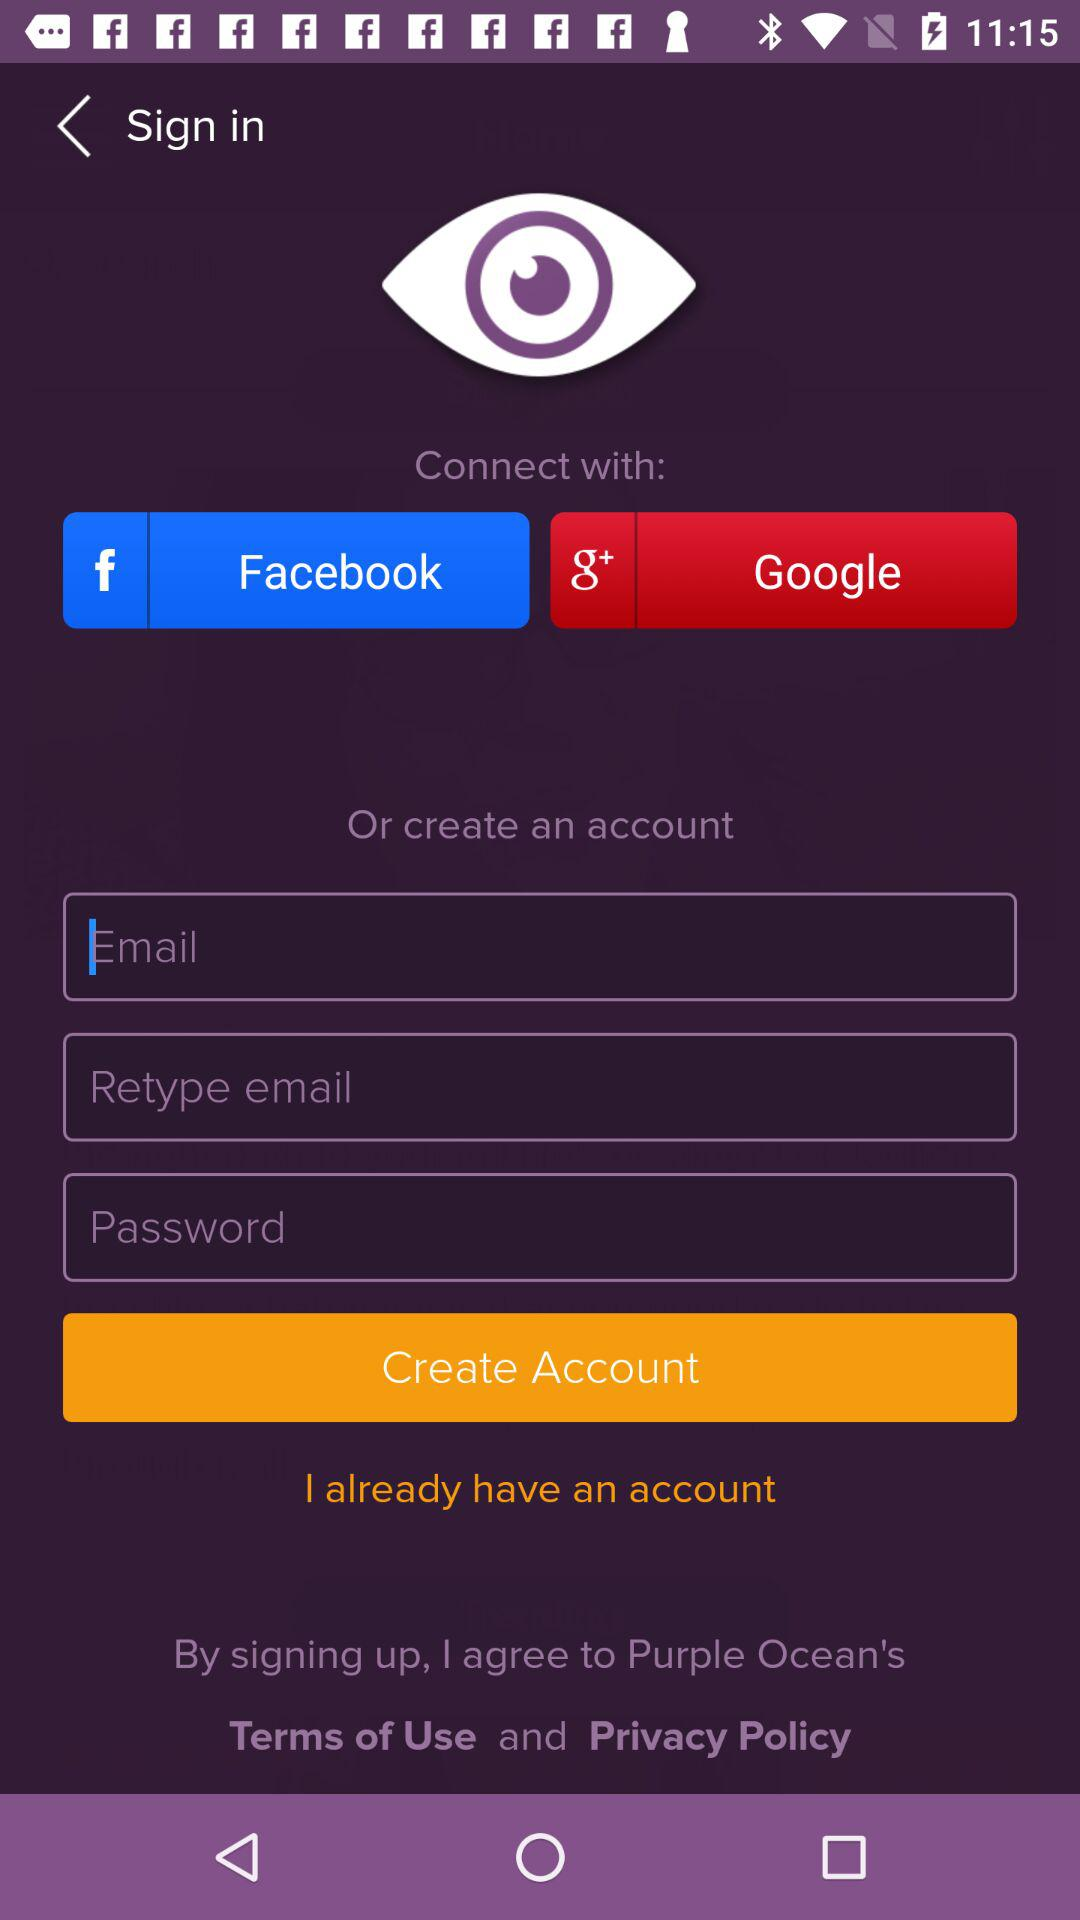Through which application can it be connected? The applications are "Facebook" and "Google+". 